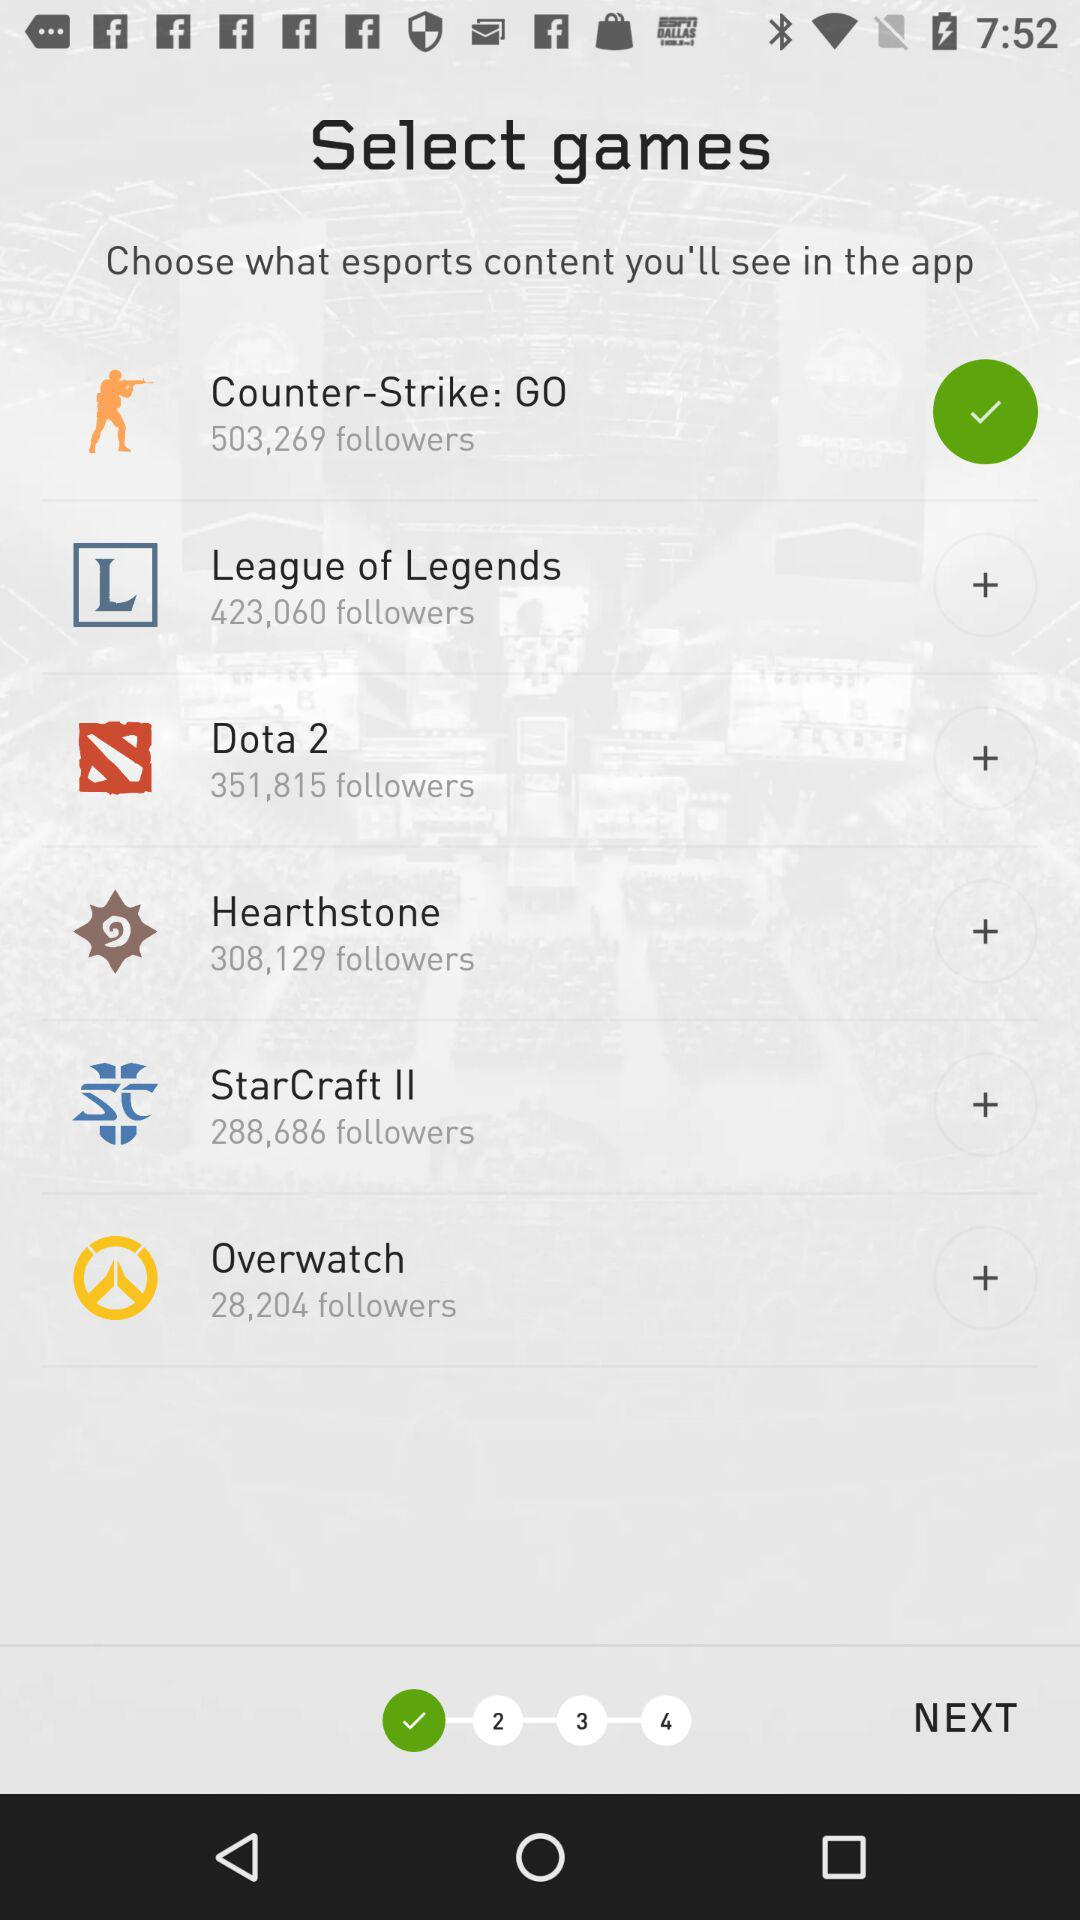How many games have more than 300,000 followers?
Answer the question using a single word or phrase. 4 